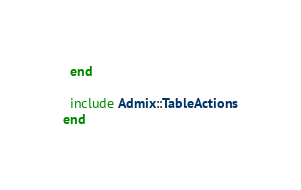<code> <loc_0><loc_0><loc_500><loc_500><_Ruby_>  end

  include Admix::TableActions
end
</code> 